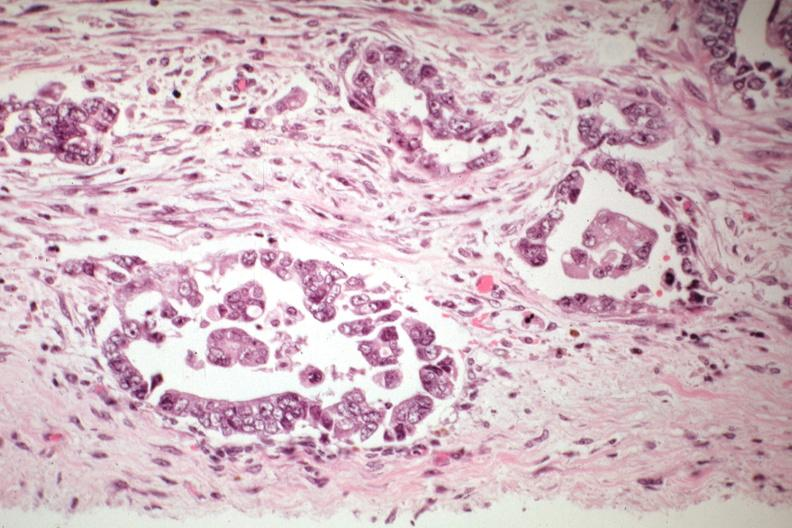does amyloid angiopathy r. endocrine show adenocarcinoma in pelvic peritoneum?
Answer the question using a single word or phrase. No 